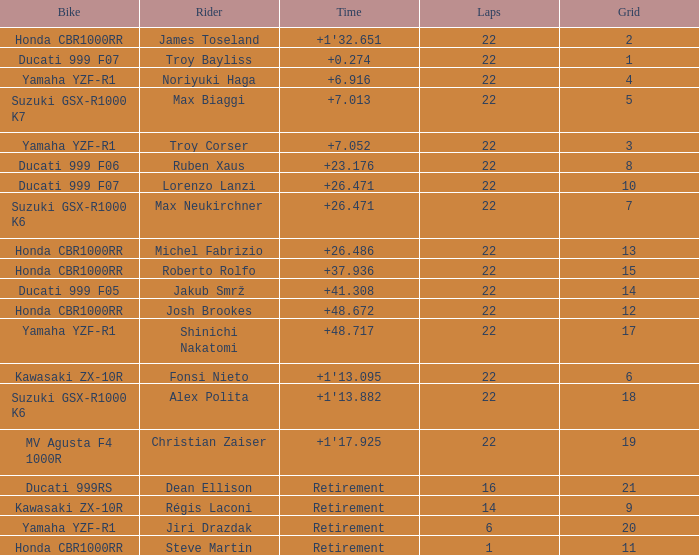What is the total grid number when Fonsi Nieto had more than 22 laps? 0.0. Could you help me parse every detail presented in this table? {'header': ['Bike', 'Rider', 'Time', 'Laps', 'Grid'], 'rows': [['Honda CBR1000RR', 'James Toseland', "+1'32.651", '22', '2'], ['Ducati 999 F07', 'Troy Bayliss', '+0.274', '22', '1'], ['Yamaha YZF-R1', 'Noriyuki Haga', '+6.916', '22', '4'], ['Suzuki GSX-R1000 K7', 'Max Biaggi', '+7.013', '22', '5'], ['Yamaha YZF-R1', 'Troy Corser', '+7.052', '22', '3'], ['Ducati 999 F06', 'Ruben Xaus', '+23.176', '22', '8'], ['Ducati 999 F07', 'Lorenzo Lanzi', '+26.471', '22', '10'], ['Suzuki GSX-R1000 K6', 'Max Neukirchner', '+26.471', '22', '7'], ['Honda CBR1000RR', 'Michel Fabrizio', '+26.486', '22', '13'], ['Honda CBR1000RR', 'Roberto Rolfo', '+37.936', '22', '15'], ['Ducati 999 F05', 'Jakub Smrž', '+41.308', '22', '14'], ['Honda CBR1000RR', 'Josh Brookes', '+48.672', '22', '12'], ['Yamaha YZF-R1', 'Shinichi Nakatomi', '+48.717', '22', '17'], ['Kawasaki ZX-10R', 'Fonsi Nieto', "+1'13.095", '22', '6'], ['Suzuki GSX-R1000 K6', 'Alex Polita', "+1'13.882", '22', '18'], ['MV Agusta F4 1000R', 'Christian Zaiser', "+1'17.925", '22', '19'], ['Ducati 999RS', 'Dean Ellison', 'Retirement', '16', '21'], ['Kawasaki ZX-10R', 'Régis Laconi', 'Retirement', '14', '9'], ['Yamaha YZF-R1', 'Jiri Drazdak', 'Retirement', '6', '20'], ['Honda CBR1000RR', 'Steve Martin', 'Retirement', '1', '11']]} 